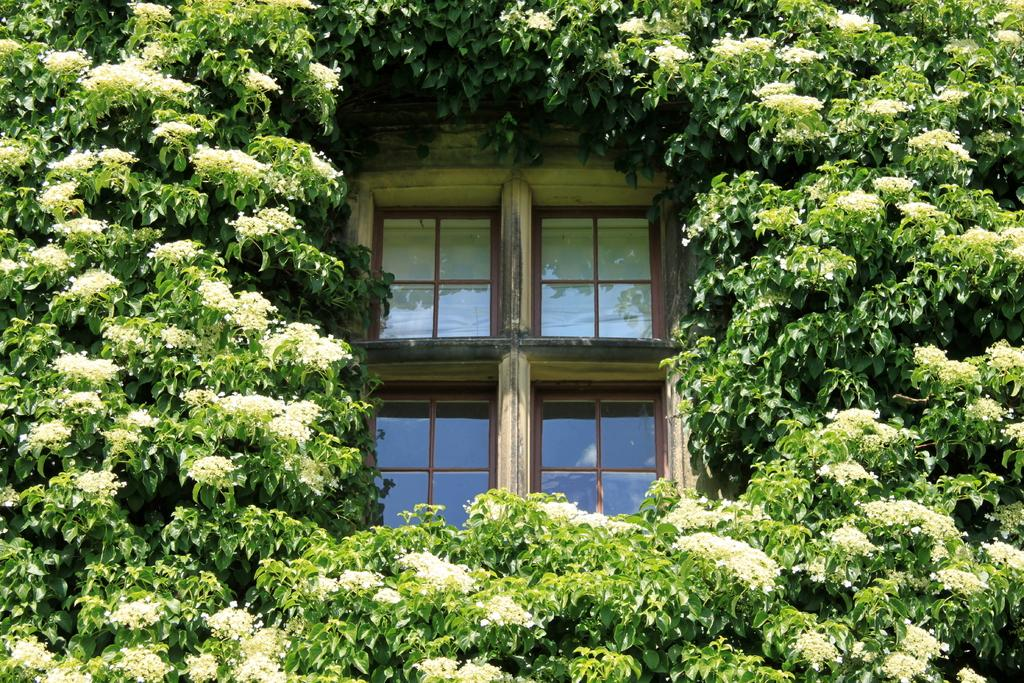What type of plant is featured in the image? There is a tree with many leaves and flowers in the image. Can you describe the unique feature of the tree? There is a glass window in the middle of the leaves. What is visible behind the glass window? There is a white wall behind the glass window. What type of peace can be seen in the image? There is no reference to peace in the image; it features a tree with a glass window and a white wall. 